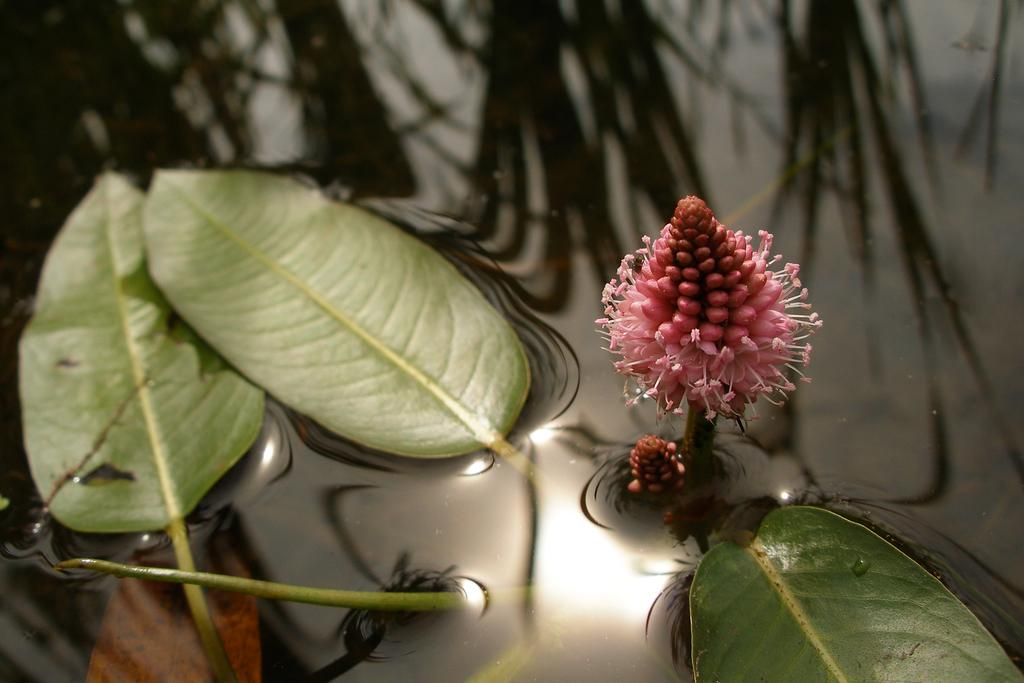What is the main subject of the image? The main subject of the image is a flower. What else can be seen in the image besides the flower? There are leaves in the image. Where are the flower and leaves located? The flower and leaves are on water. What type of selection process is being used to choose the best goldfish in the image? There are no goldfish present in the image, so there is no selection process taking place. 